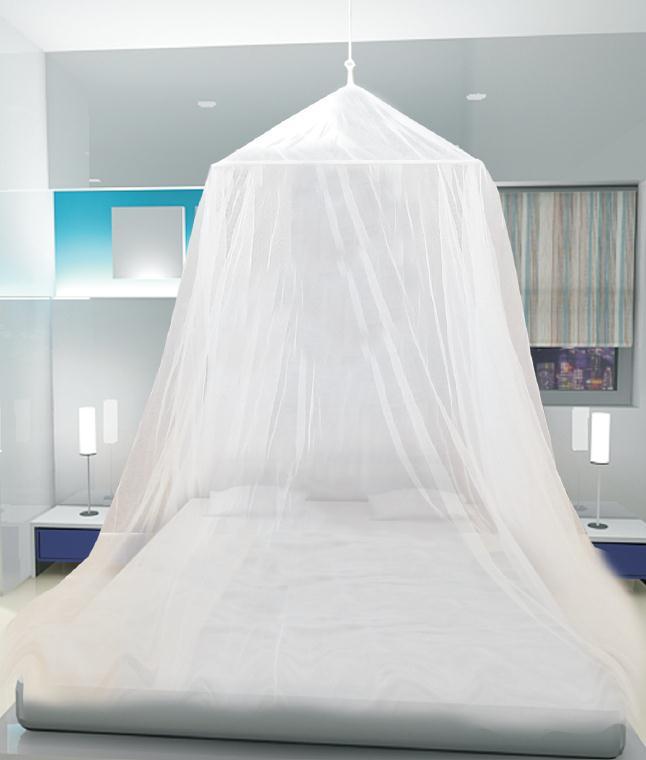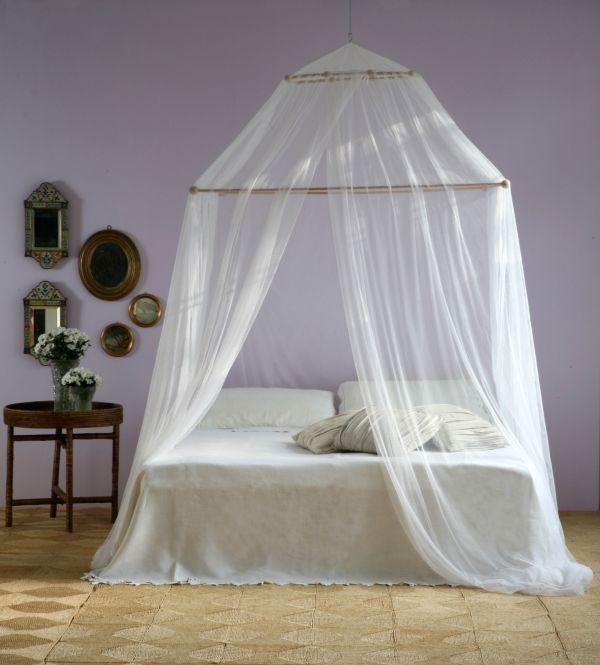The first image is the image on the left, the second image is the image on the right. Examine the images to the left and right. Is the description "One of the walls has at least one rectangular picture hanging from it." accurate? Answer yes or no. No. The first image is the image on the left, the second image is the image on the right. Evaluate the accuracy of this statement regarding the images: "At least one image shows a bed with a wooden headboard.". Is it true? Answer yes or no. No. 